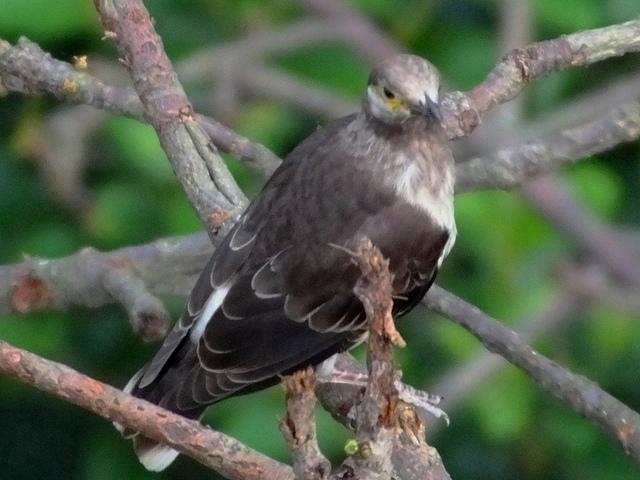What is the bird sitting on?
Give a very brief answer. Branch. Is the bird trying to fly?
Be succinct. No. What is the bird doing?
Quick response, please. Sitting on branch. Which direction is the bird looking?
Quick response, please. Right. What is the bird eating?
Concise answer only. Worm. 